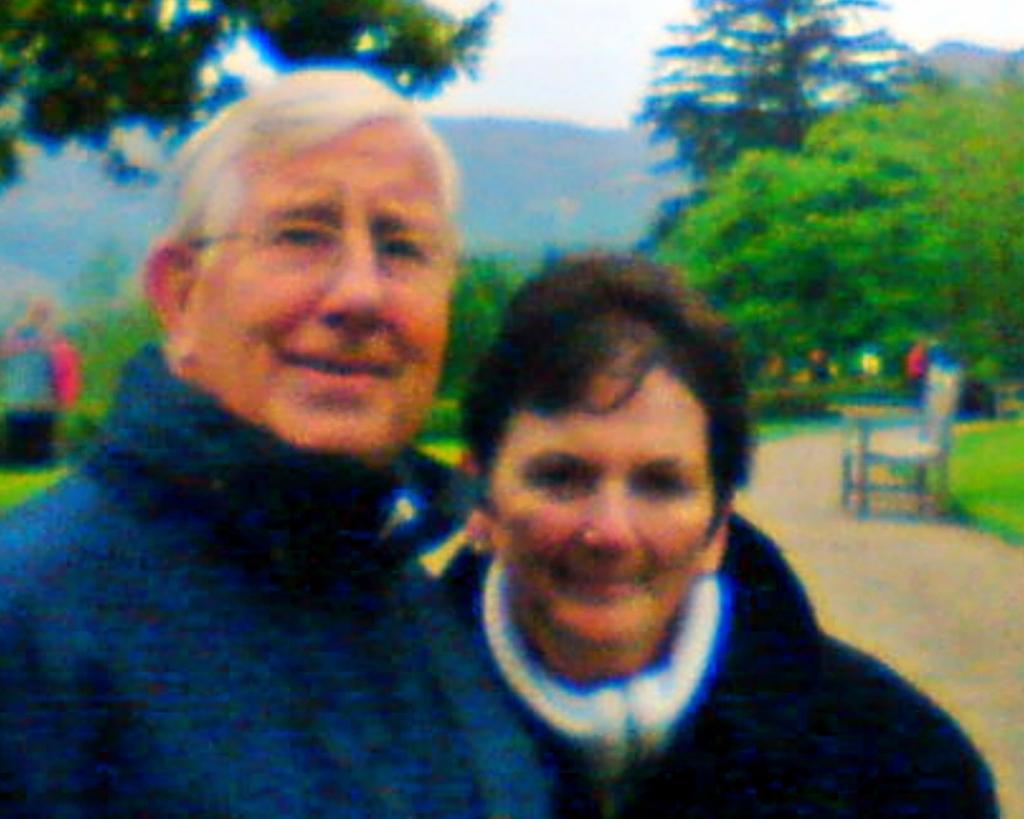Please provide a concise description of this image. In this picture we can see a old man and a woman smiling and giving a pose into the camera. Behind we can see a blur background with some trees. 